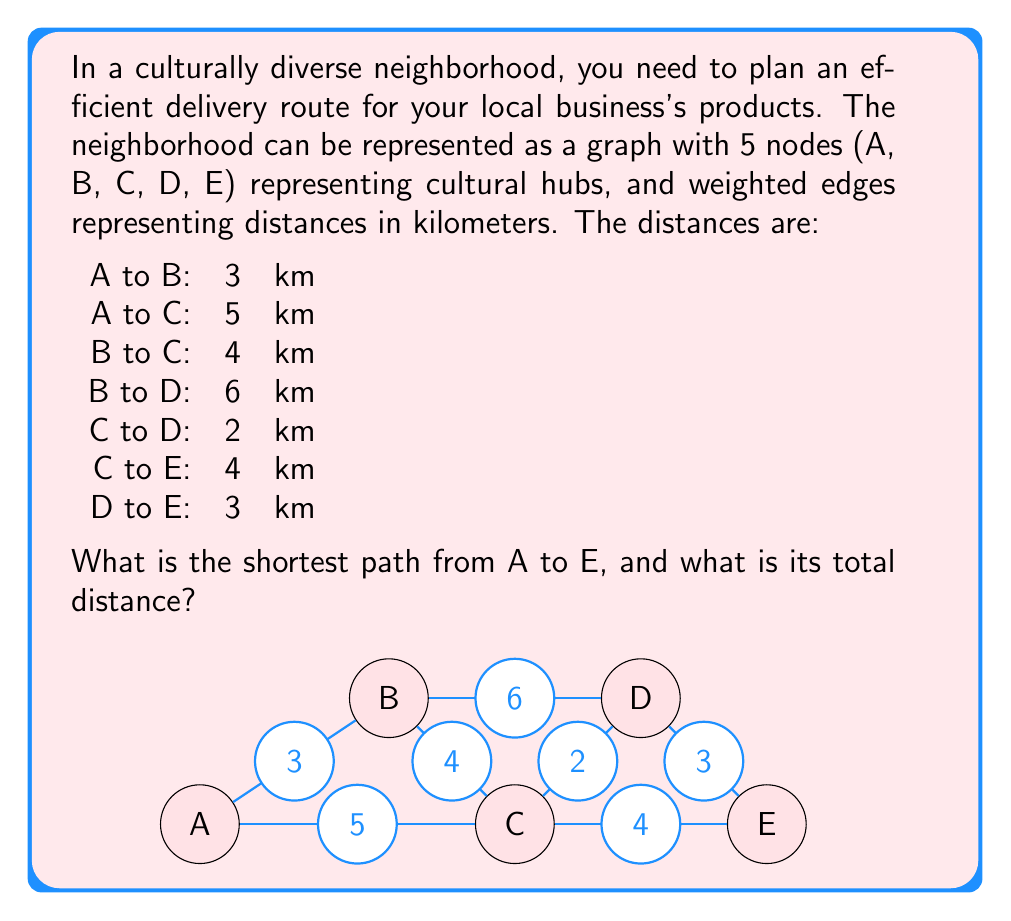Teach me how to tackle this problem. To solve this problem, we can use Dijkstra's algorithm to find the shortest path from A to E. Let's go through the steps:

1) Initialize distances:
   A: 0 (starting point)
   B: $\infty$
   C: $\infty$
   D: $\infty$
   E: $\infty$

2) Visit A:
   Update B: min($\infty$, 0 + 3) = 3
   Update C: min($\infty$, 0 + 5) = 5

3) Visit B (closest unvisited node):
   Update C: min(5, 3 + 4) = 5 (no change)
   Update D: min($\infty$, 3 + 6) = 9

4) Visit C (next closest):
   Update D: min(9, 5 + 2) = 7
   Update E: min($\infty$, 5 + 4) = 9

5) Visit D:
   Update E: min(9, 7 + 3) = 9 (no change)

6) Visit E (destination reached)

The shortest path is A -> C -> D -> E with a total distance of 5 + 2 + 3 = 10 km.

This route allows the business owner to efficiently deliver products while passing through key cultural hubs in the neighborhood, potentially increasing visibility and connecting with diverse customer bases.
Answer: The shortest path from A to E is A -> C -> D -> E, with a total distance of 10 km. 